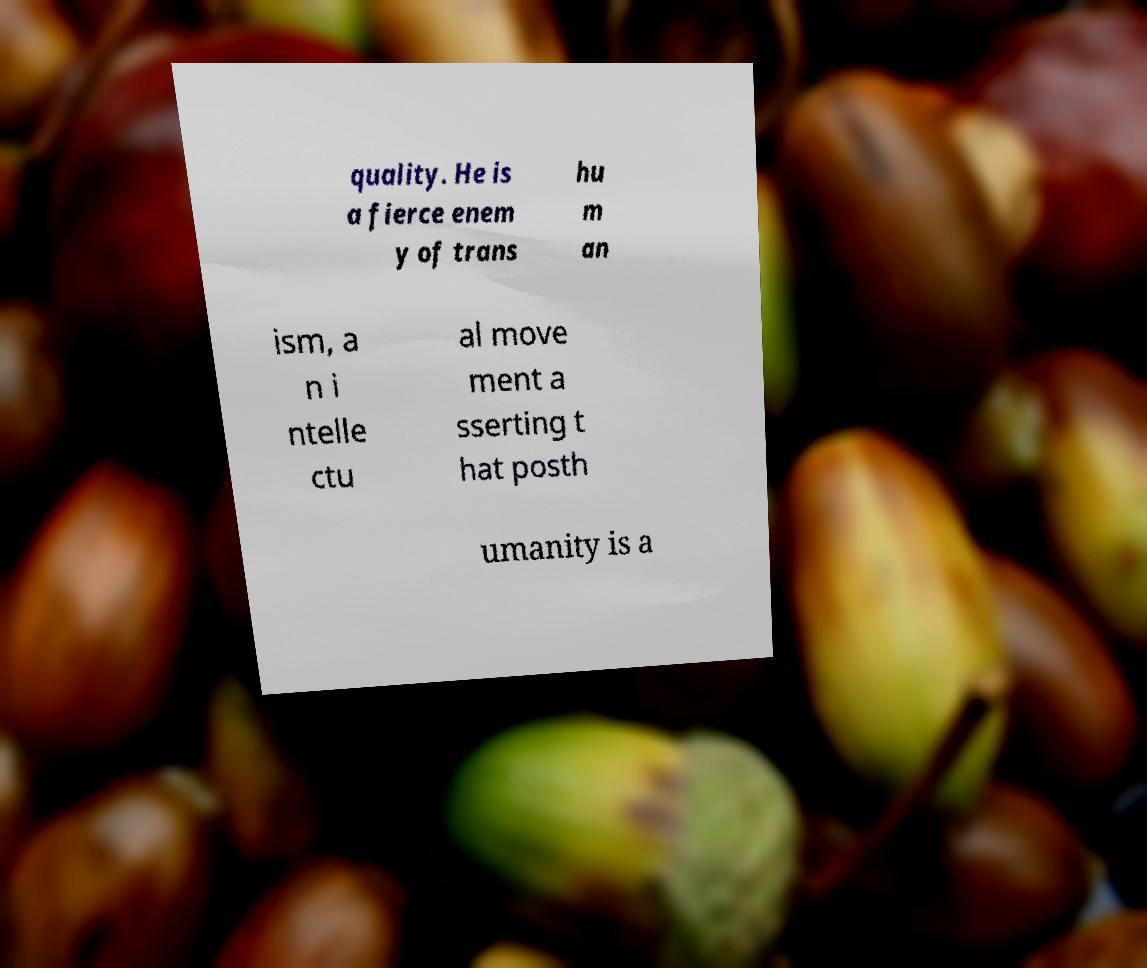Could you assist in decoding the text presented in this image and type it out clearly? quality. He is a fierce enem y of trans hu m an ism, a n i ntelle ctu al move ment a sserting t hat posth umanity is a 